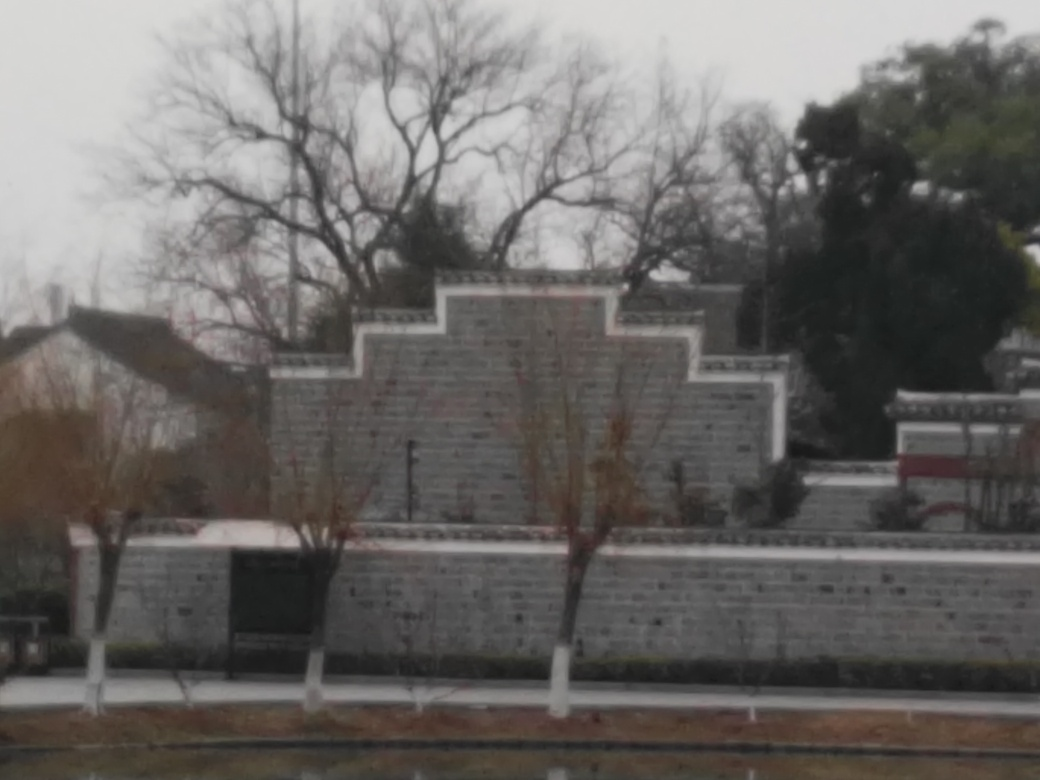Can you describe the architectural style visible in the image? The architecture showcased in the image seems modern with its clean lines and the use of what appears to be gray masonry or concrete blocks in its construction. The repeating patterns and modular design give it a contemporary and possibly functional aesthetic. 